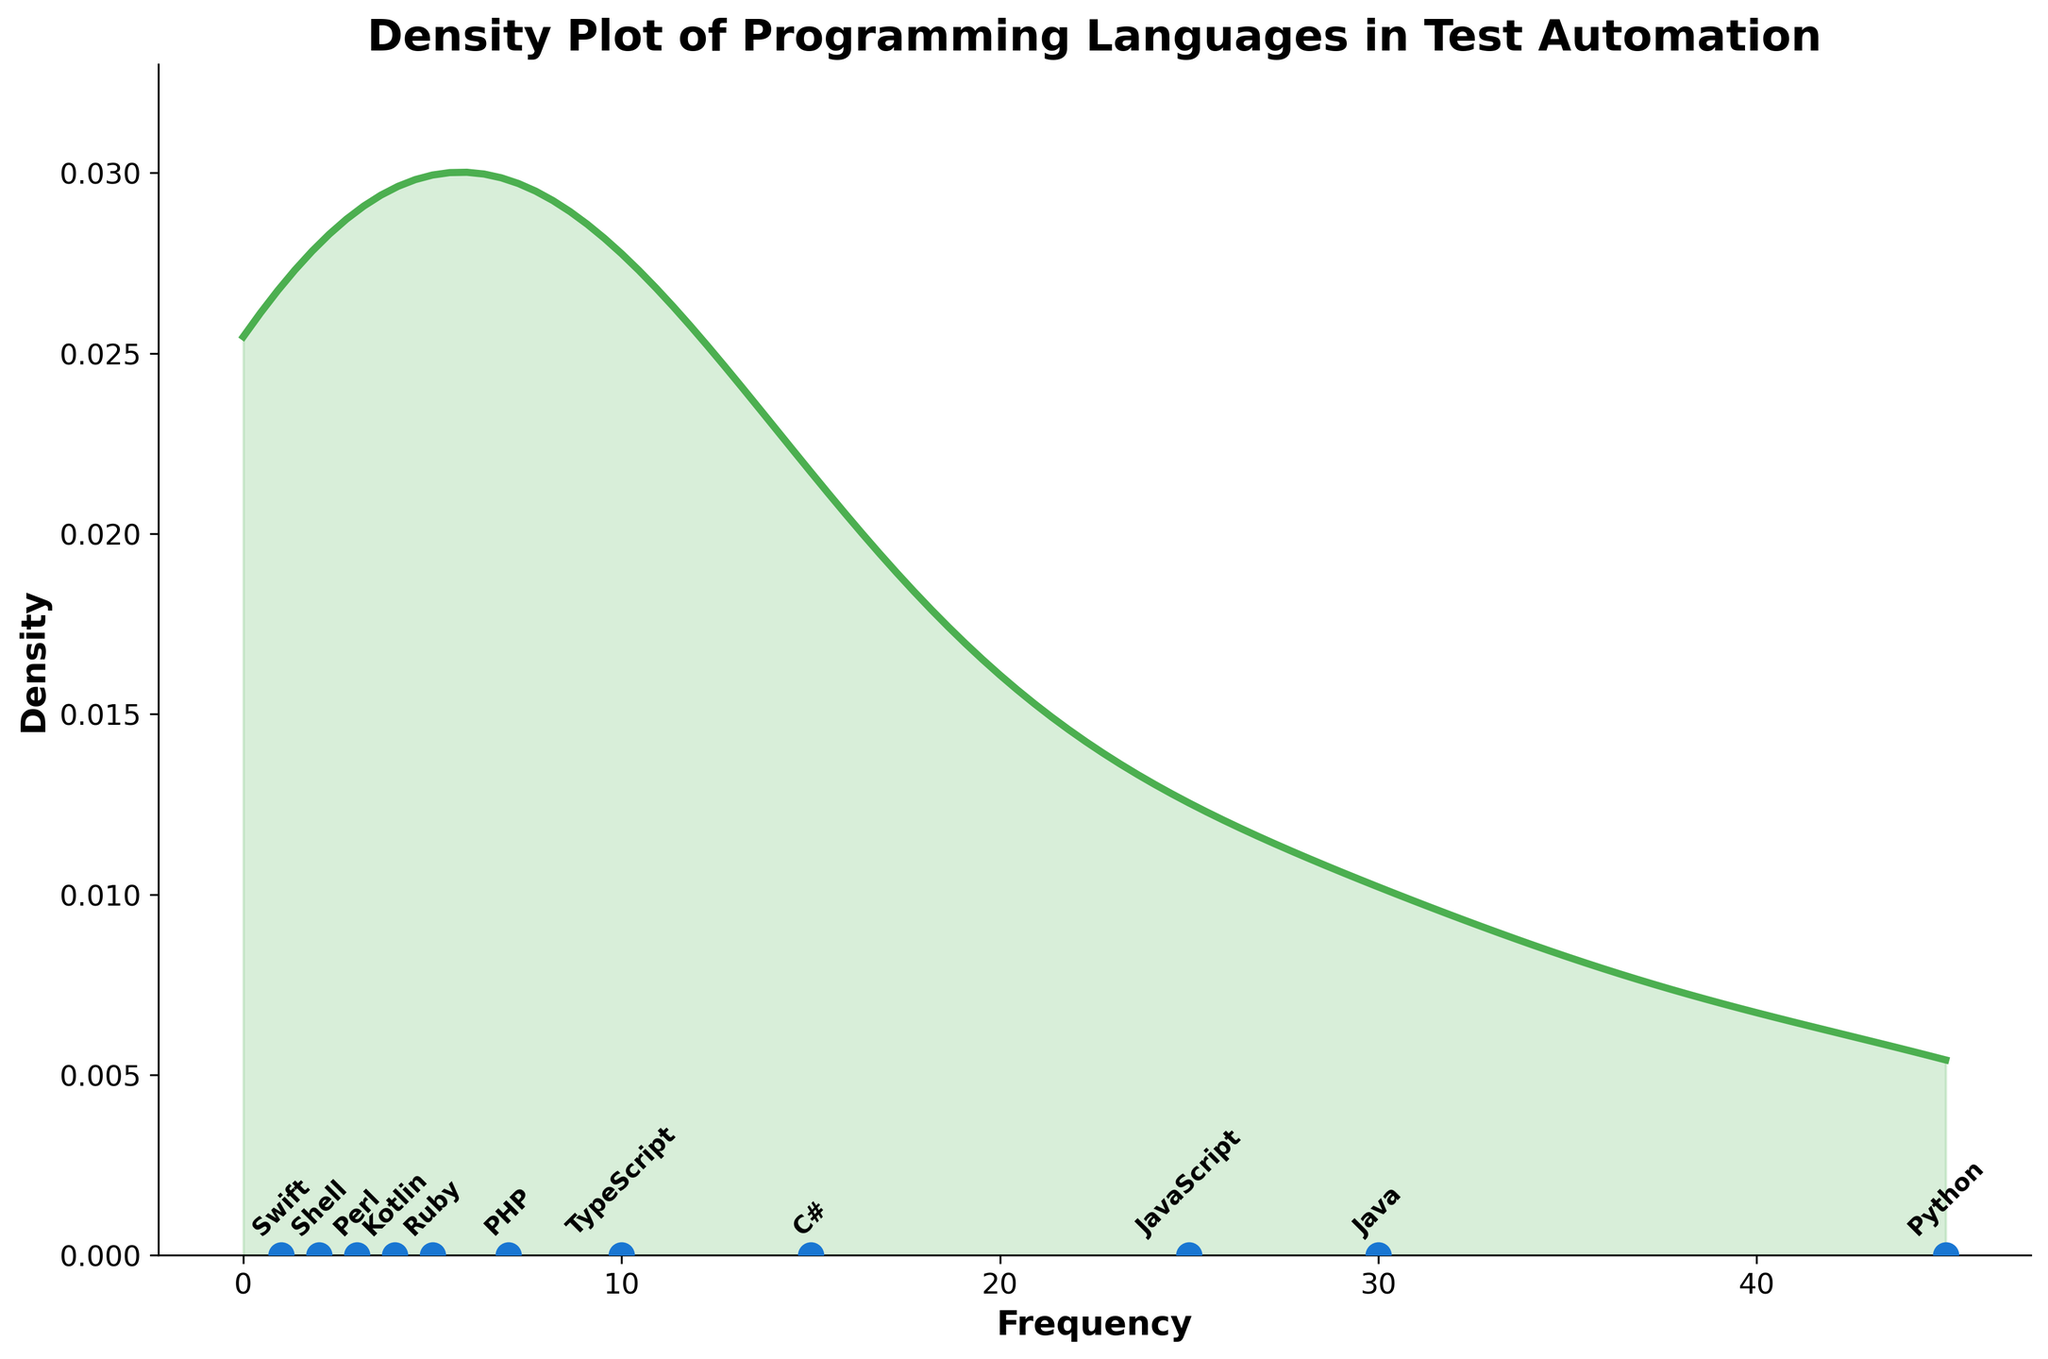How many different programming languages are plotted? By counting the annotated labels or data points on the scatter plot, we can see there are labels for each language.
Answer: 11 Which programming language has the highest frequency in test automation scripts? The annotated label for 'Python' is located at the farthest right position on the x-axis, indicating the highest frequency.
Answer: Python What is the range of frequencies among the languages in the plot? The frequencies span from the maximum value (Python with 45) to the minimum value (Swift with 1). Hence the range is 45 - 1.
Answer: 44 Name two programming languages with frequencies between 10 and 30. By inspecting the scatter plot and reading the annotated labels, we observe that 'JavaScript' (25) and 'TypeScript' (10) fall within this range.
Answer: JavaScript and TypeScript How does the density change as the frequency increases? The density curve rises initially, peaks around a middle range of frequencies, and then falls as the frequency continues to increase. This indicates a higher concentration of languages with median frequencies.
Answer: Increases then decreases Which two languages have the closest frequency values? By inspecting the scatter points and their annotated labels, we see 'PHP' (7) and 'Kotlin' (4) are relatively close, but not the closest. However, 'Kotlin' (4) and 'Ruby' (5) are indeed the closest.
Answer: Kotlin and Ruby What does the peak of the density curve indicate in the context of the data? The peak of the density curve signifies the frequency where most values are clustered, suggesting a common usage frequency for several languages.
Answer: Common usage frequency cluster What could be the reason for the least density at the beginning and end of the frequency range? The initial and terminal parts of the frequency range show lower densities due to fewer programming languages having extremely low or high frequencies. The scatter points are less crowded in these areas.
Answer: Fewer languages with extreme frequencies Estimate the frequency value around which the density reaches its peak. Observing the density curve, the peak seems to occur around the middle frequencies. By approximate visual estimation, the peak appears around the frequency value of 10-20.
Answer: Around 15 